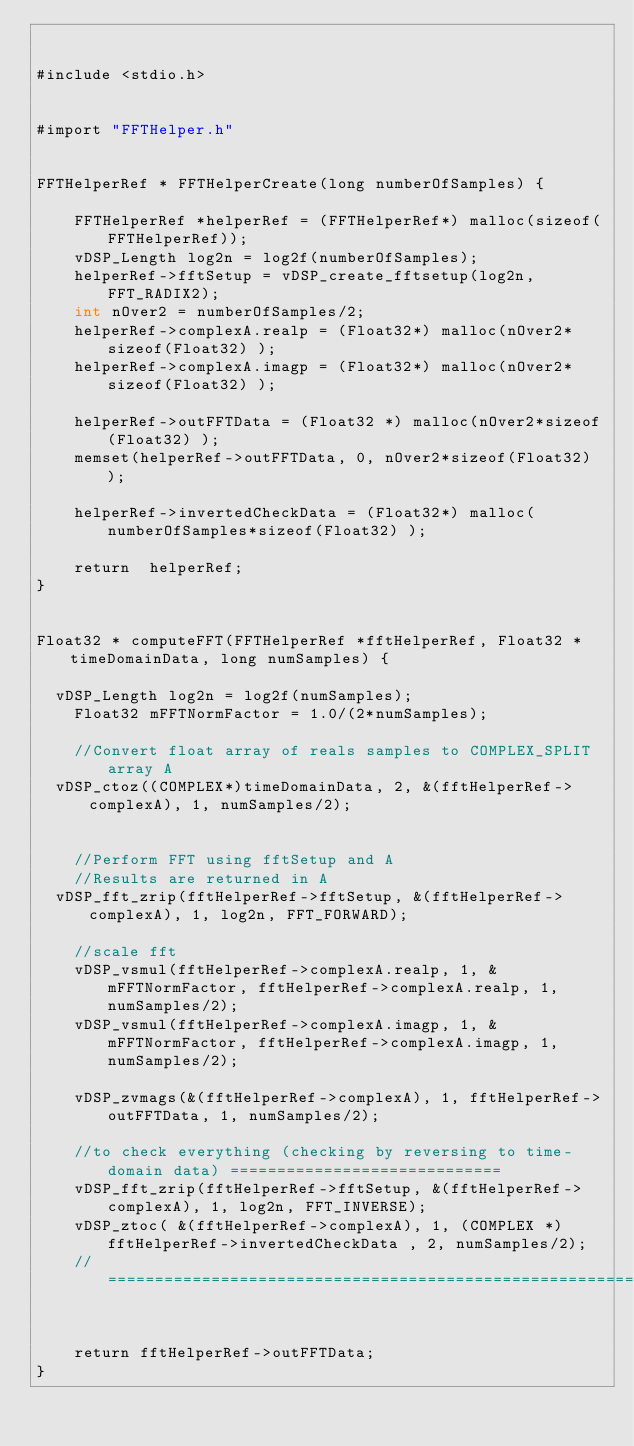<code> <loc_0><loc_0><loc_500><loc_500><_ObjectiveC_>

#include <stdio.h>


#import "FFTHelper.h"


FFTHelperRef * FFTHelperCreate(long numberOfSamples) {

    FFTHelperRef *helperRef = (FFTHelperRef*) malloc(sizeof(FFTHelperRef));
    vDSP_Length log2n = log2f(numberOfSamples);    
    helperRef->fftSetup = vDSP_create_fftsetup(log2n, FFT_RADIX2);
    int nOver2 = numberOfSamples/2;
    helperRef->complexA.realp = (Float32*) malloc(nOver2*sizeof(Float32) );
    helperRef->complexA.imagp = (Float32*) malloc(nOver2*sizeof(Float32) );
    
    helperRef->outFFTData = (Float32 *) malloc(nOver2*sizeof(Float32) );
    memset(helperRef->outFFTData, 0, nOver2*sizeof(Float32) );

    helperRef->invertedCheckData = (Float32*) malloc(numberOfSamples*sizeof(Float32) );
    
    return  helperRef;
}


Float32 * computeFFT(FFTHelperRef *fftHelperRef, Float32 *timeDomainData, long numSamples) {
    
	vDSP_Length log2n = log2f(numSamples);
    Float32 mFFTNormFactor = 1.0/(2*numSamples);
    
    //Convert float array of reals samples to COMPLEX_SPLIT array A
	vDSP_ctoz((COMPLEX*)timeDomainData, 2, &(fftHelperRef->complexA), 1, numSamples/2);
    
    
    //Perform FFT using fftSetup and A
    //Results are returned in A
	vDSP_fft_zrip(fftHelperRef->fftSetup, &(fftHelperRef->complexA), 1, log2n, FFT_FORWARD);
    
    //scale fft 
    vDSP_vsmul(fftHelperRef->complexA.realp, 1, &mFFTNormFactor, fftHelperRef->complexA.realp, 1, numSamples/2);
    vDSP_vsmul(fftHelperRef->complexA.imagp, 1, &mFFTNormFactor, fftHelperRef->complexA.imagp, 1, numSamples/2);
    
    vDSP_zvmags(&(fftHelperRef->complexA), 1, fftHelperRef->outFFTData, 1, numSamples/2);
    
    //to check everything (checking by reversing to time-domain data) =============================
    vDSP_fft_zrip(fftHelperRef->fftSetup, &(fftHelperRef->complexA), 1, log2n, FFT_INVERSE);
    vDSP_ztoc( &(fftHelperRef->complexA), 1, (COMPLEX *) fftHelperRef->invertedCheckData , 2, numSamples/2);
    //=============================================================================================

    
    return fftHelperRef->outFFTData;
}




</code> 